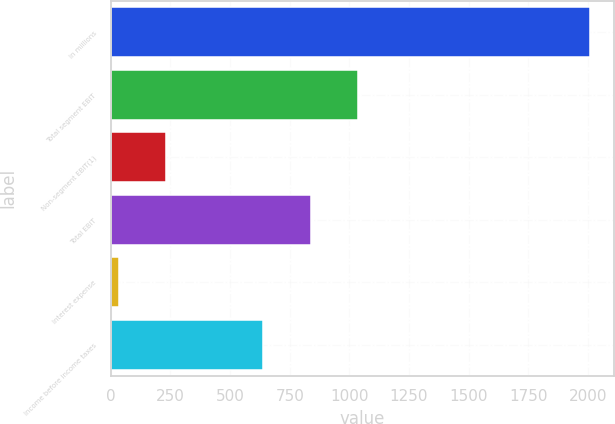<chart> <loc_0><loc_0><loc_500><loc_500><bar_chart><fcel>In millions<fcel>Total segment EBIT<fcel>Non-segment EBIT(1)<fcel>Total EBIT<fcel>Interest expense<fcel>Income before income taxes<nl><fcel>2009<fcel>1034.8<fcel>232.4<fcel>837.4<fcel>35<fcel>640<nl></chart> 